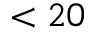<formula> <loc_0><loc_0><loc_500><loc_500>< 2 0</formula> 